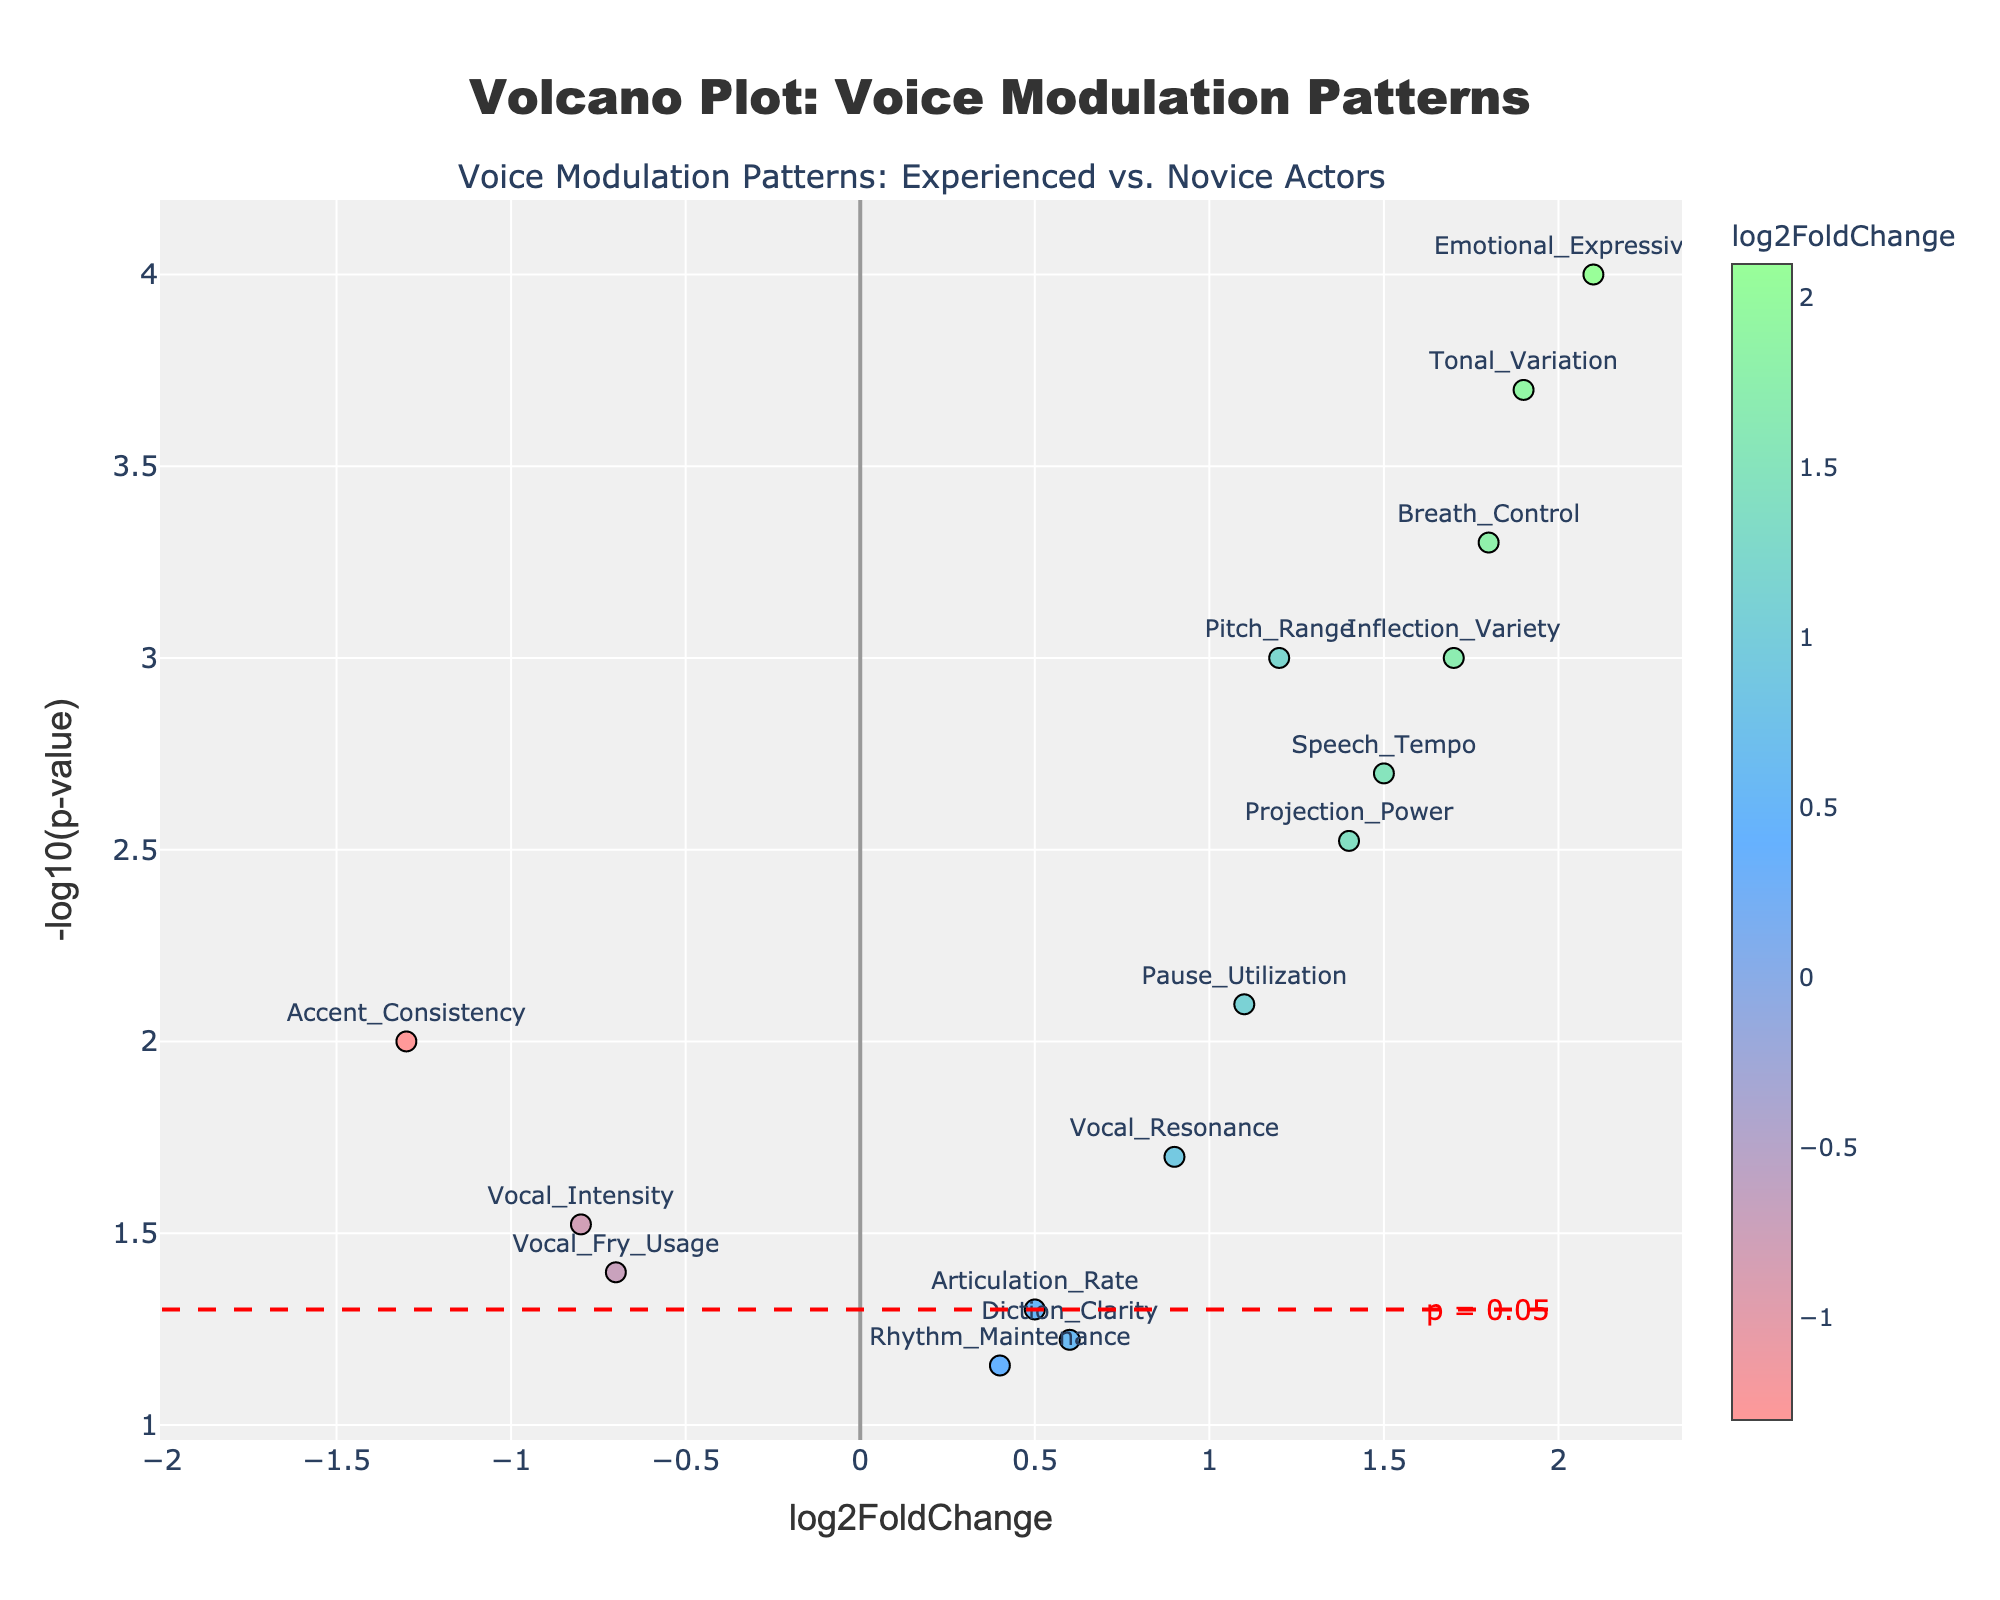How many data points are represented in the Volcano Plot? Count the number of data points in the plot by checking the labelled markers.
Answer: 14 What is the title of the Volcano Plot? Read the title displayed at the top of the plot.
Answer: Voice Modulation Patterns: Experienced vs. Novice Actors What axis represents the log2FoldChange values? Identify the axis label corresponding to log2FoldChange values.
Answer: x-axis Which modulation pattern has the highest log2FoldChange value? Look for the data point with the highest value on the x-axis and note the gene name.
Answer: Emotional_Expressiveness What is the significance threshold for p-values depicted in the plot? Locate the horizontal line on the y-axis and the annotation text near it.
Answer: p = 0.05 Are there any modulation patterns with significant p-values but negative log2FoldChange? If so, which ones? Search for data points below the p-value significance line on the y-axis and with negative log2FoldChange values on the x-axis.
Answer: Vocal_Intensity, Accent_Consistency, Vocal_Fry_Usage What is the log2FoldChange value of Breath_Control and is it statistically significant? Find the Breath_Control data point and read its x-axis value and check if it's above the y-axis significance threshold line.
Answer: 1.8, Yes Which modulation pattern has the highest -log10(p-value)? Identify the highest data point on the y-axis and note the gene name.
Answer: Emotional_Expressiveness Compare the log2FoldChange values of Projection_Power and Speech_Tempo. Which one is higher? Find the data points of Projection_Power and Speech_Tempo and compare their x-axis values.
Answer: Projection_Power What is the y-axis value of Tonal_Variation? Locate the Tonal_Variation data point and read its y-axis value.
Answer: 3.70 